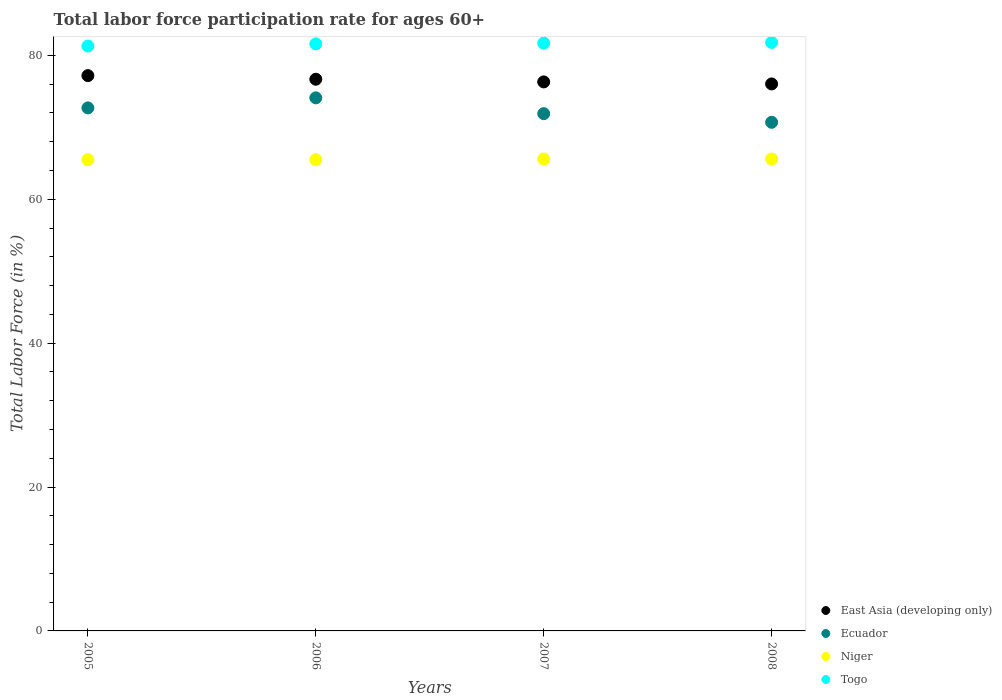What is the labor force participation rate in Ecuador in 2007?
Provide a short and direct response. 71.9. Across all years, what is the maximum labor force participation rate in Niger?
Provide a short and direct response. 65.6. Across all years, what is the minimum labor force participation rate in Niger?
Give a very brief answer. 65.5. In which year was the labor force participation rate in Niger maximum?
Keep it short and to the point. 2007. In which year was the labor force participation rate in Ecuador minimum?
Provide a short and direct response. 2008. What is the total labor force participation rate in Niger in the graph?
Your answer should be compact. 262.2. What is the difference between the labor force participation rate in Togo in 2005 and that in 2006?
Your answer should be compact. -0.3. What is the difference between the labor force participation rate in Togo in 2006 and the labor force participation rate in Niger in 2007?
Provide a short and direct response. 16. What is the average labor force participation rate in Niger per year?
Offer a very short reply. 65.55. In the year 2008, what is the difference between the labor force participation rate in Togo and labor force participation rate in Niger?
Your answer should be very brief. 16.2. In how many years, is the labor force participation rate in Togo greater than 12 %?
Ensure brevity in your answer.  4. What is the ratio of the labor force participation rate in Niger in 2005 to that in 2006?
Your response must be concise. 1. Is the labor force participation rate in Togo in 2006 less than that in 2008?
Offer a terse response. Yes. What is the difference between the highest and the second highest labor force participation rate in Togo?
Your response must be concise. 0.1. What is the difference between the highest and the lowest labor force participation rate in Niger?
Provide a succinct answer. 0.1. In how many years, is the labor force participation rate in East Asia (developing only) greater than the average labor force participation rate in East Asia (developing only) taken over all years?
Offer a terse response. 2. What is the difference between two consecutive major ticks on the Y-axis?
Keep it short and to the point. 20. Are the values on the major ticks of Y-axis written in scientific E-notation?
Your answer should be very brief. No. Where does the legend appear in the graph?
Your answer should be very brief. Bottom right. How are the legend labels stacked?
Offer a very short reply. Vertical. What is the title of the graph?
Provide a short and direct response. Total labor force participation rate for ages 60+. Does "Moldova" appear as one of the legend labels in the graph?
Ensure brevity in your answer.  No. What is the label or title of the X-axis?
Provide a succinct answer. Years. What is the Total Labor Force (in %) in East Asia (developing only) in 2005?
Make the answer very short. 77.19. What is the Total Labor Force (in %) of Ecuador in 2005?
Offer a very short reply. 72.7. What is the Total Labor Force (in %) of Niger in 2005?
Give a very brief answer. 65.5. What is the Total Labor Force (in %) of Togo in 2005?
Your answer should be compact. 81.3. What is the Total Labor Force (in %) in East Asia (developing only) in 2006?
Keep it short and to the point. 76.69. What is the Total Labor Force (in %) in Ecuador in 2006?
Give a very brief answer. 74.1. What is the Total Labor Force (in %) of Niger in 2006?
Offer a very short reply. 65.5. What is the Total Labor Force (in %) in Togo in 2006?
Offer a terse response. 81.6. What is the Total Labor Force (in %) in East Asia (developing only) in 2007?
Give a very brief answer. 76.32. What is the Total Labor Force (in %) in Ecuador in 2007?
Give a very brief answer. 71.9. What is the Total Labor Force (in %) in Niger in 2007?
Make the answer very short. 65.6. What is the Total Labor Force (in %) of Togo in 2007?
Your answer should be very brief. 81.7. What is the Total Labor Force (in %) of East Asia (developing only) in 2008?
Offer a terse response. 76.03. What is the Total Labor Force (in %) of Ecuador in 2008?
Make the answer very short. 70.7. What is the Total Labor Force (in %) of Niger in 2008?
Your response must be concise. 65.6. What is the Total Labor Force (in %) of Togo in 2008?
Offer a terse response. 81.8. Across all years, what is the maximum Total Labor Force (in %) of East Asia (developing only)?
Make the answer very short. 77.19. Across all years, what is the maximum Total Labor Force (in %) in Ecuador?
Your answer should be compact. 74.1. Across all years, what is the maximum Total Labor Force (in %) of Niger?
Your response must be concise. 65.6. Across all years, what is the maximum Total Labor Force (in %) of Togo?
Offer a very short reply. 81.8. Across all years, what is the minimum Total Labor Force (in %) in East Asia (developing only)?
Provide a short and direct response. 76.03. Across all years, what is the minimum Total Labor Force (in %) of Ecuador?
Offer a very short reply. 70.7. Across all years, what is the minimum Total Labor Force (in %) in Niger?
Provide a short and direct response. 65.5. Across all years, what is the minimum Total Labor Force (in %) of Togo?
Your answer should be compact. 81.3. What is the total Total Labor Force (in %) in East Asia (developing only) in the graph?
Give a very brief answer. 306.22. What is the total Total Labor Force (in %) of Ecuador in the graph?
Provide a short and direct response. 289.4. What is the total Total Labor Force (in %) of Niger in the graph?
Provide a short and direct response. 262.2. What is the total Total Labor Force (in %) of Togo in the graph?
Your answer should be very brief. 326.4. What is the difference between the Total Labor Force (in %) in East Asia (developing only) in 2005 and that in 2006?
Your response must be concise. 0.5. What is the difference between the Total Labor Force (in %) in Niger in 2005 and that in 2006?
Your response must be concise. 0. What is the difference between the Total Labor Force (in %) in Togo in 2005 and that in 2006?
Your answer should be very brief. -0.3. What is the difference between the Total Labor Force (in %) in East Asia (developing only) in 2005 and that in 2007?
Your answer should be compact. 0.87. What is the difference between the Total Labor Force (in %) in Ecuador in 2005 and that in 2007?
Your answer should be compact. 0.8. What is the difference between the Total Labor Force (in %) in Niger in 2005 and that in 2007?
Keep it short and to the point. -0.1. What is the difference between the Total Labor Force (in %) of East Asia (developing only) in 2005 and that in 2008?
Offer a very short reply. 1.16. What is the difference between the Total Labor Force (in %) in Niger in 2005 and that in 2008?
Provide a short and direct response. -0.1. What is the difference between the Total Labor Force (in %) of Togo in 2005 and that in 2008?
Provide a short and direct response. -0.5. What is the difference between the Total Labor Force (in %) in East Asia (developing only) in 2006 and that in 2007?
Make the answer very short. 0.37. What is the difference between the Total Labor Force (in %) of Ecuador in 2006 and that in 2007?
Your response must be concise. 2.2. What is the difference between the Total Labor Force (in %) of Togo in 2006 and that in 2007?
Offer a terse response. -0.1. What is the difference between the Total Labor Force (in %) in East Asia (developing only) in 2006 and that in 2008?
Make the answer very short. 0.65. What is the difference between the Total Labor Force (in %) in Ecuador in 2006 and that in 2008?
Make the answer very short. 3.4. What is the difference between the Total Labor Force (in %) in East Asia (developing only) in 2007 and that in 2008?
Your response must be concise. 0.28. What is the difference between the Total Labor Force (in %) in Ecuador in 2007 and that in 2008?
Keep it short and to the point. 1.2. What is the difference between the Total Labor Force (in %) in East Asia (developing only) in 2005 and the Total Labor Force (in %) in Ecuador in 2006?
Your response must be concise. 3.09. What is the difference between the Total Labor Force (in %) of East Asia (developing only) in 2005 and the Total Labor Force (in %) of Niger in 2006?
Keep it short and to the point. 11.69. What is the difference between the Total Labor Force (in %) of East Asia (developing only) in 2005 and the Total Labor Force (in %) of Togo in 2006?
Your answer should be compact. -4.41. What is the difference between the Total Labor Force (in %) of Ecuador in 2005 and the Total Labor Force (in %) of Niger in 2006?
Your answer should be compact. 7.2. What is the difference between the Total Labor Force (in %) of Ecuador in 2005 and the Total Labor Force (in %) of Togo in 2006?
Provide a succinct answer. -8.9. What is the difference between the Total Labor Force (in %) of Niger in 2005 and the Total Labor Force (in %) of Togo in 2006?
Your answer should be very brief. -16.1. What is the difference between the Total Labor Force (in %) in East Asia (developing only) in 2005 and the Total Labor Force (in %) in Ecuador in 2007?
Give a very brief answer. 5.29. What is the difference between the Total Labor Force (in %) in East Asia (developing only) in 2005 and the Total Labor Force (in %) in Niger in 2007?
Offer a very short reply. 11.59. What is the difference between the Total Labor Force (in %) of East Asia (developing only) in 2005 and the Total Labor Force (in %) of Togo in 2007?
Ensure brevity in your answer.  -4.51. What is the difference between the Total Labor Force (in %) of Niger in 2005 and the Total Labor Force (in %) of Togo in 2007?
Give a very brief answer. -16.2. What is the difference between the Total Labor Force (in %) in East Asia (developing only) in 2005 and the Total Labor Force (in %) in Ecuador in 2008?
Keep it short and to the point. 6.49. What is the difference between the Total Labor Force (in %) in East Asia (developing only) in 2005 and the Total Labor Force (in %) in Niger in 2008?
Provide a short and direct response. 11.59. What is the difference between the Total Labor Force (in %) in East Asia (developing only) in 2005 and the Total Labor Force (in %) in Togo in 2008?
Provide a succinct answer. -4.61. What is the difference between the Total Labor Force (in %) in Niger in 2005 and the Total Labor Force (in %) in Togo in 2008?
Your response must be concise. -16.3. What is the difference between the Total Labor Force (in %) in East Asia (developing only) in 2006 and the Total Labor Force (in %) in Ecuador in 2007?
Give a very brief answer. 4.79. What is the difference between the Total Labor Force (in %) in East Asia (developing only) in 2006 and the Total Labor Force (in %) in Niger in 2007?
Your answer should be very brief. 11.09. What is the difference between the Total Labor Force (in %) of East Asia (developing only) in 2006 and the Total Labor Force (in %) of Togo in 2007?
Give a very brief answer. -5.01. What is the difference between the Total Labor Force (in %) of Ecuador in 2006 and the Total Labor Force (in %) of Togo in 2007?
Make the answer very short. -7.6. What is the difference between the Total Labor Force (in %) of Niger in 2006 and the Total Labor Force (in %) of Togo in 2007?
Give a very brief answer. -16.2. What is the difference between the Total Labor Force (in %) of East Asia (developing only) in 2006 and the Total Labor Force (in %) of Ecuador in 2008?
Ensure brevity in your answer.  5.99. What is the difference between the Total Labor Force (in %) of East Asia (developing only) in 2006 and the Total Labor Force (in %) of Niger in 2008?
Offer a very short reply. 11.09. What is the difference between the Total Labor Force (in %) of East Asia (developing only) in 2006 and the Total Labor Force (in %) of Togo in 2008?
Your answer should be compact. -5.11. What is the difference between the Total Labor Force (in %) of Niger in 2006 and the Total Labor Force (in %) of Togo in 2008?
Offer a terse response. -16.3. What is the difference between the Total Labor Force (in %) of East Asia (developing only) in 2007 and the Total Labor Force (in %) of Ecuador in 2008?
Provide a short and direct response. 5.62. What is the difference between the Total Labor Force (in %) of East Asia (developing only) in 2007 and the Total Labor Force (in %) of Niger in 2008?
Your answer should be very brief. 10.72. What is the difference between the Total Labor Force (in %) in East Asia (developing only) in 2007 and the Total Labor Force (in %) in Togo in 2008?
Make the answer very short. -5.48. What is the difference between the Total Labor Force (in %) in Niger in 2007 and the Total Labor Force (in %) in Togo in 2008?
Offer a terse response. -16.2. What is the average Total Labor Force (in %) of East Asia (developing only) per year?
Ensure brevity in your answer.  76.56. What is the average Total Labor Force (in %) of Ecuador per year?
Give a very brief answer. 72.35. What is the average Total Labor Force (in %) in Niger per year?
Make the answer very short. 65.55. What is the average Total Labor Force (in %) of Togo per year?
Offer a terse response. 81.6. In the year 2005, what is the difference between the Total Labor Force (in %) in East Asia (developing only) and Total Labor Force (in %) in Ecuador?
Your response must be concise. 4.49. In the year 2005, what is the difference between the Total Labor Force (in %) in East Asia (developing only) and Total Labor Force (in %) in Niger?
Make the answer very short. 11.69. In the year 2005, what is the difference between the Total Labor Force (in %) of East Asia (developing only) and Total Labor Force (in %) of Togo?
Your answer should be very brief. -4.11. In the year 2005, what is the difference between the Total Labor Force (in %) in Ecuador and Total Labor Force (in %) in Niger?
Provide a short and direct response. 7.2. In the year 2005, what is the difference between the Total Labor Force (in %) of Niger and Total Labor Force (in %) of Togo?
Provide a short and direct response. -15.8. In the year 2006, what is the difference between the Total Labor Force (in %) of East Asia (developing only) and Total Labor Force (in %) of Ecuador?
Offer a terse response. 2.59. In the year 2006, what is the difference between the Total Labor Force (in %) of East Asia (developing only) and Total Labor Force (in %) of Niger?
Offer a terse response. 11.19. In the year 2006, what is the difference between the Total Labor Force (in %) in East Asia (developing only) and Total Labor Force (in %) in Togo?
Make the answer very short. -4.91. In the year 2006, what is the difference between the Total Labor Force (in %) of Ecuador and Total Labor Force (in %) of Togo?
Offer a very short reply. -7.5. In the year 2006, what is the difference between the Total Labor Force (in %) of Niger and Total Labor Force (in %) of Togo?
Offer a terse response. -16.1. In the year 2007, what is the difference between the Total Labor Force (in %) of East Asia (developing only) and Total Labor Force (in %) of Ecuador?
Ensure brevity in your answer.  4.42. In the year 2007, what is the difference between the Total Labor Force (in %) in East Asia (developing only) and Total Labor Force (in %) in Niger?
Your response must be concise. 10.72. In the year 2007, what is the difference between the Total Labor Force (in %) in East Asia (developing only) and Total Labor Force (in %) in Togo?
Offer a terse response. -5.38. In the year 2007, what is the difference between the Total Labor Force (in %) in Ecuador and Total Labor Force (in %) in Togo?
Offer a terse response. -9.8. In the year 2007, what is the difference between the Total Labor Force (in %) of Niger and Total Labor Force (in %) of Togo?
Give a very brief answer. -16.1. In the year 2008, what is the difference between the Total Labor Force (in %) in East Asia (developing only) and Total Labor Force (in %) in Ecuador?
Your answer should be compact. 5.33. In the year 2008, what is the difference between the Total Labor Force (in %) in East Asia (developing only) and Total Labor Force (in %) in Niger?
Give a very brief answer. 10.43. In the year 2008, what is the difference between the Total Labor Force (in %) in East Asia (developing only) and Total Labor Force (in %) in Togo?
Your response must be concise. -5.77. In the year 2008, what is the difference between the Total Labor Force (in %) in Ecuador and Total Labor Force (in %) in Niger?
Keep it short and to the point. 5.1. In the year 2008, what is the difference between the Total Labor Force (in %) of Niger and Total Labor Force (in %) of Togo?
Offer a terse response. -16.2. What is the ratio of the Total Labor Force (in %) in East Asia (developing only) in 2005 to that in 2006?
Your answer should be compact. 1.01. What is the ratio of the Total Labor Force (in %) in Ecuador in 2005 to that in 2006?
Ensure brevity in your answer.  0.98. What is the ratio of the Total Labor Force (in %) of East Asia (developing only) in 2005 to that in 2007?
Your answer should be compact. 1.01. What is the ratio of the Total Labor Force (in %) of Ecuador in 2005 to that in 2007?
Offer a very short reply. 1.01. What is the ratio of the Total Labor Force (in %) in East Asia (developing only) in 2005 to that in 2008?
Provide a succinct answer. 1.02. What is the ratio of the Total Labor Force (in %) of Ecuador in 2005 to that in 2008?
Your response must be concise. 1.03. What is the ratio of the Total Labor Force (in %) of Ecuador in 2006 to that in 2007?
Ensure brevity in your answer.  1.03. What is the ratio of the Total Labor Force (in %) of Niger in 2006 to that in 2007?
Make the answer very short. 1. What is the ratio of the Total Labor Force (in %) in Togo in 2006 to that in 2007?
Ensure brevity in your answer.  1. What is the ratio of the Total Labor Force (in %) of East Asia (developing only) in 2006 to that in 2008?
Your answer should be compact. 1.01. What is the ratio of the Total Labor Force (in %) of Ecuador in 2006 to that in 2008?
Your response must be concise. 1.05. What is the ratio of the Total Labor Force (in %) of Ecuador in 2007 to that in 2008?
Provide a succinct answer. 1.02. What is the difference between the highest and the second highest Total Labor Force (in %) of East Asia (developing only)?
Your answer should be very brief. 0.5. What is the difference between the highest and the second highest Total Labor Force (in %) of Niger?
Give a very brief answer. 0. What is the difference between the highest and the second highest Total Labor Force (in %) in Togo?
Keep it short and to the point. 0.1. What is the difference between the highest and the lowest Total Labor Force (in %) in East Asia (developing only)?
Provide a short and direct response. 1.16. 